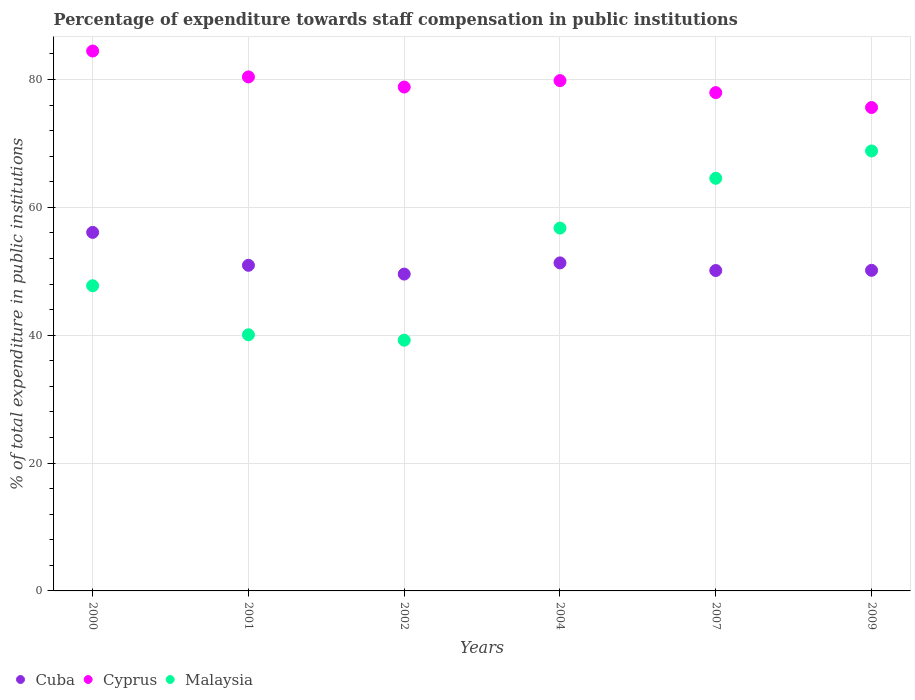What is the percentage of expenditure towards staff compensation in Cuba in 2000?
Ensure brevity in your answer.  56.08. Across all years, what is the maximum percentage of expenditure towards staff compensation in Malaysia?
Give a very brief answer. 68.82. Across all years, what is the minimum percentage of expenditure towards staff compensation in Cyprus?
Provide a short and direct response. 75.61. In which year was the percentage of expenditure towards staff compensation in Cuba maximum?
Provide a succinct answer. 2000. In which year was the percentage of expenditure towards staff compensation in Cyprus minimum?
Your answer should be compact. 2009. What is the total percentage of expenditure towards staff compensation in Cyprus in the graph?
Make the answer very short. 477.02. What is the difference between the percentage of expenditure towards staff compensation in Malaysia in 2000 and that in 2002?
Keep it short and to the point. 8.52. What is the difference between the percentage of expenditure towards staff compensation in Malaysia in 2009 and the percentage of expenditure towards staff compensation in Cyprus in 2007?
Your answer should be very brief. -9.12. What is the average percentage of expenditure towards staff compensation in Cyprus per year?
Give a very brief answer. 79.5. In the year 2004, what is the difference between the percentage of expenditure towards staff compensation in Malaysia and percentage of expenditure towards staff compensation in Cuba?
Make the answer very short. 5.44. In how many years, is the percentage of expenditure towards staff compensation in Malaysia greater than 28 %?
Provide a short and direct response. 6. What is the ratio of the percentage of expenditure towards staff compensation in Cyprus in 2000 to that in 2007?
Make the answer very short. 1.08. What is the difference between the highest and the second highest percentage of expenditure towards staff compensation in Cyprus?
Give a very brief answer. 4.05. What is the difference between the highest and the lowest percentage of expenditure towards staff compensation in Cuba?
Your answer should be compact. 6.52. Is the percentage of expenditure towards staff compensation in Cyprus strictly greater than the percentage of expenditure towards staff compensation in Malaysia over the years?
Offer a terse response. Yes. How many dotlines are there?
Give a very brief answer. 3. How many years are there in the graph?
Provide a succinct answer. 6. What is the difference between two consecutive major ticks on the Y-axis?
Your answer should be very brief. 20. Are the values on the major ticks of Y-axis written in scientific E-notation?
Keep it short and to the point. No. Does the graph contain any zero values?
Provide a succinct answer. No. Does the graph contain grids?
Make the answer very short. Yes. How many legend labels are there?
Provide a succinct answer. 3. How are the legend labels stacked?
Provide a short and direct response. Horizontal. What is the title of the graph?
Offer a terse response. Percentage of expenditure towards staff compensation in public institutions. What is the label or title of the Y-axis?
Offer a terse response. % of total expenditure in public institutions. What is the % of total expenditure in public institutions of Cuba in 2000?
Your answer should be compact. 56.08. What is the % of total expenditure in public institutions in Cyprus in 2000?
Your response must be concise. 84.44. What is the % of total expenditure in public institutions in Malaysia in 2000?
Provide a succinct answer. 47.73. What is the % of total expenditure in public institutions in Cuba in 2001?
Provide a succinct answer. 50.93. What is the % of total expenditure in public institutions of Cyprus in 2001?
Offer a terse response. 80.4. What is the % of total expenditure in public institutions in Malaysia in 2001?
Offer a terse response. 40.07. What is the % of total expenditure in public institutions in Cuba in 2002?
Your answer should be very brief. 49.56. What is the % of total expenditure in public institutions of Cyprus in 2002?
Ensure brevity in your answer.  78.81. What is the % of total expenditure in public institutions of Malaysia in 2002?
Keep it short and to the point. 39.22. What is the % of total expenditure in public institutions in Cuba in 2004?
Your answer should be compact. 51.31. What is the % of total expenditure in public institutions of Cyprus in 2004?
Your response must be concise. 79.82. What is the % of total expenditure in public institutions in Malaysia in 2004?
Provide a succinct answer. 56.75. What is the % of total expenditure in public institutions of Cuba in 2007?
Offer a very short reply. 50.11. What is the % of total expenditure in public institutions in Cyprus in 2007?
Give a very brief answer. 77.94. What is the % of total expenditure in public institutions in Malaysia in 2007?
Provide a short and direct response. 64.54. What is the % of total expenditure in public institutions in Cuba in 2009?
Your response must be concise. 50.14. What is the % of total expenditure in public institutions of Cyprus in 2009?
Make the answer very short. 75.61. What is the % of total expenditure in public institutions of Malaysia in 2009?
Provide a short and direct response. 68.82. Across all years, what is the maximum % of total expenditure in public institutions in Cuba?
Provide a short and direct response. 56.08. Across all years, what is the maximum % of total expenditure in public institutions in Cyprus?
Give a very brief answer. 84.44. Across all years, what is the maximum % of total expenditure in public institutions of Malaysia?
Your answer should be compact. 68.82. Across all years, what is the minimum % of total expenditure in public institutions of Cuba?
Your response must be concise. 49.56. Across all years, what is the minimum % of total expenditure in public institutions of Cyprus?
Make the answer very short. 75.61. Across all years, what is the minimum % of total expenditure in public institutions of Malaysia?
Provide a short and direct response. 39.22. What is the total % of total expenditure in public institutions of Cuba in the graph?
Keep it short and to the point. 308.13. What is the total % of total expenditure in public institutions of Cyprus in the graph?
Provide a succinct answer. 477.02. What is the total % of total expenditure in public institutions of Malaysia in the graph?
Your answer should be very brief. 317.12. What is the difference between the % of total expenditure in public institutions of Cuba in 2000 and that in 2001?
Offer a very short reply. 5.15. What is the difference between the % of total expenditure in public institutions in Cyprus in 2000 and that in 2001?
Ensure brevity in your answer.  4.05. What is the difference between the % of total expenditure in public institutions of Malaysia in 2000 and that in 2001?
Keep it short and to the point. 7.67. What is the difference between the % of total expenditure in public institutions in Cuba in 2000 and that in 2002?
Your answer should be very brief. 6.52. What is the difference between the % of total expenditure in public institutions of Cyprus in 2000 and that in 2002?
Ensure brevity in your answer.  5.63. What is the difference between the % of total expenditure in public institutions in Malaysia in 2000 and that in 2002?
Make the answer very short. 8.52. What is the difference between the % of total expenditure in public institutions of Cuba in 2000 and that in 2004?
Offer a terse response. 4.77. What is the difference between the % of total expenditure in public institutions in Cyprus in 2000 and that in 2004?
Keep it short and to the point. 4.63. What is the difference between the % of total expenditure in public institutions in Malaysia in 2000 and that in 2004?
Provide a short and direct response. -9.02. What is the difference between the % of total expenditure in public institutions in Cuba in 2000 and that in 2007?
Provide a short and direct response. 5.96. What is the difference between the % of total expenditure in public institutions in Cyprus in 2000 and that in 2007?
Give a very brief answer. 6.5. What is the difference between the % of total expenditure in public institutions of Malaysia in 2000 and that in 2007?
Make the answer very short. -16.81. What is the difference between the % of total expenditure in public institutions in Cuba in 2000 and that in 2009?
Offer a very short reply. 5.93. What is the difference between the % of total expenditure in public institutions of Cyprus in 2000 and that in 2009?
Give a very brief answer. 8.83. What is the difference between the % of total expenditure in public institutions in Malaysia in 2000 and that in 2009?
Offer a very short reply. -21.08. What is the difference between the % of total expenditure in public institutions of Cuba in 2001 and that in 2002?
Offer a very short reply. 1.37. What is the difference between the % of total expenditure in public institutions in Cyprus in 2001 and that in 2002?
Your answer should be compact. 1.59. What is the difference between the % of total expenditure in public institutions in Malaysia in 2001 and that in 2002?
Offer a very short reply. 0.85. What is the difference between the % of total expenditure in public institutions of Cuba in 2001 and that in 2004?
Ensure brevity in your answer.  -0.38. What is the difference between the % of total expenditure in public institutions of Cyprus in 2001 and that in 2004?
Offer a terse response. 0.58. What is the difference between the % of total expenditure in public institutions of Malaysia in 2001 and that in 2004?
Provide a succinct answer. -16.69. What is the difference between the % of total expenditure in public institutions in Cuba in 2001 and that in 2007?
Make the answer very short. 0.82. What is the difference between the % of total expenditure in public institutions in Cyprus in 2001 and that in 2007?
Give a very brief answer. 2.46. What is the difference between the % of total expenditure in public institutions in Malaysia in 2001 and that in 2007?
Provide a short and direct response. -24.47. What is the difference between the % of total expenditure in public institutions of Cuba in 2001 and that in 2009?
Your answer should be very brief. 0.79. What is the difference between the % of total expenditure in public institutions in Cyprus in 2001 and that in 2009?
Keep it short and to the point. 4.79. What is the difference between the % of total expenditure in public institutions in Malaysia in 2001 and that in 2009?
Offer a terse response. -28.75. What is the difference between the % of total expenditure in public institutions of Cuba in 2002 and that in 2004?
Ensure brevity in your answer.  -1.75. What is the difference between the % of total expenditure in public institutions of Cyprus in 2002 and that in 2004?
Your answer should be very brief. -1.01. What is the difference between the % of total expenditure in public institutions of Malaysia in 2002 and that in 2004?
Your response must be concise. -17.53. What is the difference between the % of total expenditure in public institutions in Cuba in 2002 and that in 2007?
Your answer should be very brief. -0.56. What is the difference between the % of total expenditure in public institutions of Cyprus in 2002 and that in 2007?
Offer a very short reply. 0.87. What is the difference between the % of total expenditure in public institutions of Malaysia in 2002 and that in 2007?
Your response must be concise. -25.32. What is the difference between the % of total expenditure in public institutions of Cuba in 2002 and that in 2009?
Your answer should be very brief. -0.59. What is the difference between the % of total expenditure in public institutions in Cyprus in 2002 and that in 2009?
Offer a terse response. 3.2. What is the difference between the % of total expenditure in public institutions in Malaysia in 2002 and that in 2009?
Make the answer very short. -29.6. What is the difference between the % of total expenditure in public institutions of Cuba in 2004 and that in 2007?
Ensure brevity in your answer.  1.19. What is the difference between the % of total expenditure in public institutions of Cyprus in 2004 and that in 2007?
Your answer should be very brief. 1.88. What is the difference between the % of total expenditure in public institutions of Malaysia in 2004 and that in 2007?
Provide a succinct answer. -7.79. What is the difference between the % of total expenditure in public institutions in Cuba in 2004 and that in 2009?
Offer a terse response. 1.16. What is the difference between the % of total expenditure in public institutions in Cyprus in 2004 and that in 2009?
Make the answer very short. 4.21. What is the difference between the % of total expenditure in public institutions in Malaysia in 2004 and that in 2009?
Offer a terse response. -12.06. What is the difference between the % of total expenditure in public institutions of Cuba in 2007 and that in 2009?
Your answer should be compact. -0.03. What is the difference between the % of total expenditure in public institutions of Cyprus in 2007 and that in 2009?
Provide a succinct answer. 2.33. What is the difference between the % of total expenditure in public institutions of Malaysia in 2007 and that in 2009?
Offer a terse response. -4.28. What is the difference between the % of total expenditure in public institutions of Cuba in 2000 and the % of total expenditure in public institutions of Cyprus in 2001?
Keep it short and to the point. -24.32. What is the difference between the % of total expenditure in public institutions of Cuba in 2000 and the % of total expenditure in public institutions of Malaysia in 2001?
Your response must be concise. 16.01. What is the difference between the % of total expenditure in public institutions of Cyprus in 2000 and the % of total expenditure in public institutions of Malaysia in 2001?
Your answer should be very brief. 44.38. What is the difference between the % of total expenditure in public institutions in Cuba in 2000 and the % of total expenditure in public institutions in Cyprus in 2002?
Your answer should be compact. -22.73. What is the difference between the % of total expenditure in public institutions of Cuba in 2000 and the % of total expenditure in public institutions of Malaysia in 2002?
Your response must be concise. 16.86. What is the difference between the % of total expenditure in public institutions in Cyprus in 2000 and the % of total expenditure in public institutions in Malaysia in 2002?
Your answer should be very brief. 45.23. What is the difference between the % of total expenditure in public institutions in Cuba in 2000 and the % of total expenditure in public institutions in Cyprus in 2004?
Keep it short and to the point. -23.74. What is the difference between the % of total expenditure in public institutions in Cuba in 2000 and the % of total expenditure in public institutions in Malaysia in 2004?
Make the answer very short. -0.67. What is the difference between the % of total expenditure in public institutions of Cyprus in 2000 and the % of total expenditure in public institutions of Malaysia in 2004?
Keep it short and to the point. 27.69. What is the difference between the % of total expenditure in public institutions of Cuba in 2000 and the % of total expenditure in public institutions of Cyprus in 2007?
Provide a succinct answer. -21.86. What is the difference between the % of total expenditure in public institutions in Cuba in 2000 and the % of total expenditure in public institutions in Malaysia in 2007?
Provide a succinct answer. -8.46. What is the difference between the % of total expenditure in public institutions of Cyprus in 2000 and the % of total expenditure in public institutions of Malaysia in 2007?
Offer a very short reply. 19.9. What is the difference between the % of total expenditure in public institutions in Cuba in 2000 and the % of total expenditure in public institutions in Cyprus in 2009?
Your response must be concise. -19.53. What is the difference between the % of total expenditure in public institutions of Cuba in 2000 and the % of total expenditure in public institutions of Malaysia in 2009?
Offer a terse response. -12.74. What is the difference between the % of total expenditure in public institutions of Cyprus in 2000 and the % of total expenditure in public institutions of Malaysia in 2009?
Offer a very short reply. 15.63. What is the difference between the % of total expenditure in public institutions of Cuba in 2001 and the % of total expenditure in public institutions of Cyprus in 2002?
Ensure brevity in your answer.  -27.88. What is the difference between the % of total expenditure in public institutions in Cuba in 2001 and the % of total expenditure in public institutions in Malaysia in 2002?
Offer a terse response. 11.71. What is the difference between the % of total expenditure in public institutions of Cyprus in 2001 and the % of total expenditure in public institutions of Malaysia in 2002?
Keep it short and to the point. 41.18. What is the difference between the % of total expenditure in public institutions of Cuba in 2001 and the % of total expenditure in public institutions of Cyprus in 2004?
Your answer should be compact. -28.89. What is the difference between the % of total expenditure in public institutions of Cuba in 2001 and the % of total expenditure in public institutions of Malaysia in 2004?
Your response must be concise. -5.82. What is the difference between the % of total expenditure in public institutions of Cyprus in 2001 and the % of total expenditure in public institutions of Malaysia in 2004?
Provide a succinct answer. 23.65. What is the difference between the % of total expenditure in public institutions of Cuba in 2001 and the % of total expenditure in public institutions of Cyprus in 2007?
Offer a terse response. -27.01. What is the difference between the % of total expenditure in public institutions in Cuba in 2001 and the % of total expenditure in public institutions in Malaysia in 2007?
Provide a short and direct response. -13.61. What is the difference between the % of total expenditure in public institutions of Cyprus in 2001 and the % of total expenditure in public institutions of Malaysia in 2007?
Give a very brief answer. 15.86. What is the difference between the % of total expenditure in public institutions of Cuba in 2001 and the % of total expenditure in public institutions of Cyprus in 2009?
Provide a succinct answer. -24.68. What is the difference between the % of total expenditure in public institutions of Cuba in 2001 and the % of total expenditure in public institutions of Malaysia in 2009?
Your response must be concise. -17.89. What is the difference between the % of total expenditure in public institutions in Cyprus in 2001 and the % of total expenditure in public institutions in Malaysia in 2009?
Offer a very short reply. 11.58. What is the difference between the % of total expenditure in public institutions in Cuba in 2002 and the % of total expenditure in public institutions in Cyprus in 2004?
Provide a short and direct response. -30.26. What is the difference between the % of total expenditure in public institutions of Cuba in 2002 and the % of total expenditure in public institutions of Malaysia in 2004?
Make the answer very short. -7.19. What is the difference between the % of total expenditure in public institutions in Cyprus in 2002 and the % of total expenditure in public institutions in Malaysia in 2004?
Your answer should be compact. 22.06. What is the difference between the % of total expenditure in public institutions in Cuba in 2002 and the % of total expenditure in public institutions in Cyprus in 2007?
Ensure brevity in your answer.  -28.38. What is the difference between the % of total expenditure in public institutions of Cuba in 2002 and the % of total expenditure in public institutions of Malaysia in 2007?
Provide a succinct answer. -14.98. What is the difference between the % of total expenditure in public institutions in Cyprus in 2002 and the % of total expenditure in public institutions in Malaysia in 2007?
Provide a succinct answer. 14.27. What is the difference between the % of total expenditure in public institutions of Cuba in 2002 and the % of total expenditure in public institutions of Cyprus in 2009?
Your response must be concise. -26.05. What is the difference between the % of total expenditure in public institutions of Cuba in 2002 and the % of total expenditure in public institutions of Malaysia in 2009?
Keep it short and to the point. -19.26. What is the difference between the % of total expenditure in public institutions of Cyprus in 2002 and the % of total expenditure in public institutions of Malaysia in 2009?
Provide a succinct answer. 10. What is the difference between the % of total expenditure in public institutions in Cuba in 2004 and the % of total expenditure in public institutions in Cyprus in 2007?
Make the answer very short. -26.63. What is the difference between the % of total expenditure in public institutions of Cuba in 2004 and the % of total expenditure in public institutions of Malaysia in 2007?
Ensure brevity in your answer.  -13.23. What is the difference between the % of total expenditure in public institutions in Cyprus in 2004 and the % of total expenditure in public institutions in Malaysia in 2007?
Your response must be concise. 15.28. What is the difference between the % of total expenditure in public institutions in Cuba in 2004 and the % of total expenditure in public institutions in Cyprus in 2009?
Make the answer very short. -24.3. What is the difference between the % of total expenditure in public institutions in Cuba in 2004 and the % of total expenditure in public institutions in Malaysia in 2009?
Your answer should be very brief. -17.51. What is the difference between the % of total expenditure in public institutions of Cyprus in 2004 and the % of total expenditure in public institutions of Malaysia in 2009?
Your response must be concise. 11. What is the difference between the % of total expenditure in public institutions in Cuba in 2007 and the % of total expenditure in public institutions in Cyprus in 2009?
Your response must be concise. -25.5. What is the difference between the % of total expenditure in public institutions in Cuba in 2007 and the % of total expenditure in public institutions in Malaysia in 2009?
Give a very brief answer. -18.7. What is the difference between the % of total expenditure in public institutions of Cyprus in 2007 and the % of total expenditure in public institutions of Malaysia in 2009?
Provide a succinct answer. 9.12. What is the average % of total expenditure in public institutions in Cuba per year?
Make the answer very short. 51.36. What is the average % of total expenditure in public institutions of Cyprus per year?
Keep it short and to the point. 79.5. What is the average % of total expenditure in public institutions in Malaysia per year?
Your response must be concise. 52.85. In the year 2000, what is the difference between the % of total expenditure in public institutions in Cuba and % of total expenditure in public institutions in Cyprus?
Give a very brief answer. -28.37. In the year 2000, what is the difference between the % of total expenditure in public institutions of Cuba and % of total expenditure in public institutions of Malaysia?
Ensure brevity in your answer.  8.35. In the year 2000, what is the difference between the % of total expenditure in public institutions of Cyprus and % of total expenditure in public institutions of Malaysia?
Offer a terse response. 36.71. In the year 2001, what is the difference between the % of total expenditure in public institutions of Cuba and % of total expenditure in public institutions of Cyprus?
Make the answer very short. -29.47. In the year 2001, what is the difference between the % of total expenditure in public institutions of Cuba and % of total expenditure in public institutions of Malaysia?
Give a very brief answer. 10.86. In the year 2001, what is the difference between the % of total expenditure in public institutions in Cyprus and % of total expenditure in public institutions in Malaysia?
Give a very brief answer. 40.33. In the year 2002, what is the difference between the % of total expenditure in public institutions of Cuba and % of total expenditure in public institutions of Cyprus?
Keep it short and to the point. -29.25. In the year 2002, what is the difference between the % of total expenditure in public institutions in Cuba and % of total expenditure in public institutions in Malaysia?
Provide a succinct answer. 10.34. In the year 2002, what is the difference between the % of total expenditure in public institutions of Cyprus and % of total expenditure in public institutions of Malaysia?
Make the answer very short. 39.6. In the year 2004, what is the difference between the % of total expenditure in public institutions in Cuba and % of total expenditure in public institutions in Cyprus?
Your response must be concise. -28.51. In the year 2004, what is the difference between the % of total expenditure in public institutions of Cuba and % of total expenditure in public institutions of Malaysia?
Offer a very short reply. -5.44. In the year 2004, what is the difference between the % of total expenditure in public institutions in Cyprus and % of total expenditure in public institutions in Malaysia?
Make the answer very short. 23.07. In the year 2007, what is the difference between the % of total expenditure in public institutions in Cuba and % of total expenditure in public institutions in Cyprus?
Make the answer very short. -27.83. In the year 2007, what is the difference between the % of total expenditure in public institutions of Cuba and % of total expenditure in public institutions of Malaysia?
Keep it short and to the point. -14.43. In the year 2007, what is the difference between the % of total expenditure in public institutions in Cyprus and % of total expenditure in public institutions in Malaysia?
Keep it short and to the point. 13.4. In the year 2009, what is the difference between the % of total expenditure in public institutions in Cuba and % of total expenditure in public institutions in Cyprus?
Make the answer very short. -25.47. In the year 2009, what is the difference between the % of total expenditure in public institutions in Cuba and % of total expenditure in public institutions in Malaysia?
Your response must be concise. -18.67. In the year 2009, what is the difference between the % of total expenditure in public institutions in Cyprus and % of total expenditure in public institutions in Malaysia?
Ensure brevity in your answer.  6.8. What is the ratio of the % of total expenditure in public institutions of Cuba in 2000 to that in 2001?
Keep it short and to the point. 1.1. What is the ratio of the % of total expenditure in public institutions in Cyprus in 2000 to that in 2001?
Provide a short and direct response. 1.05. What is the ratio of the % of total expenditure in public institutions of Malaysia in 2000 to that in 2001?
Your answer should be very brief. 1.19. What is the ratio of the % of total expenditure in public institutions in Cuba in 2000 to that in 2002?
Provide a succinct answer. 1.13. What is the ratio of the % of total expenditure in public institutions of Cyprus in 2000 to that in 2002?
Provide a short and direct response. 1.07. What is the ratio of the % of total expenditure in public institutions in Malaysia in 2000 to that in 2002?
Ensure brevity in your answer.  1.22. What is the ratio of the % of total expenditure in public institutions in Cuba in 2000 to that in 2004?
Your answer should be very brief. 1.09. What is the ratio of the % of total expenditure in public institutions of Cyprus in 2000 to that in 2004?
Offer a very short reply. 1.06. What is the ratio of the % of total expenditure in public institutions in Malaysia in 2000 to that in 2004?
Your answer should be very brief. 0.84. What is the ratio of the % of total expenditure in public institutions in Cuba in 2000 to that in 2007?
Keep it short and to the point. 1.12. What is the ratio of the % of total expenditure in public institutions in Cyprus in 2000 to that in 2007?
Offer a terse response. 1.08. What is the ratio of the % of total expenditure in public institutions of Malaysia in 2000 to that in 2007?
Provide a succinct answer. 0.74. What is the ratio of the % of total expenditure in public institutions in Cuba in 2000 to that in 2009?
Provide a succinct answer. 1.12. What is the ratio of the % of total expenditure in public institutions in Cyprus in 2000 to that in 2009?
Keep it short and to the point. 1.12. What is the ratio of the % of total expenditure in public institutions of Malaysia in 2000 to that in 2009?
Offer a terse response. 0.69. What is the ratio of the % of total expenditure in public institutions in Cuba in 2001 to that in 2002?
Your answer should be compact. 1.03. What is the ratio of the % of total expenditure in public institutions in Cyprus in 2001 to that in 2002?
Give a very brief answer. 1.02. What is the ratio of the % of total expenditure in public institutions in Malaysia in 2001 to that in 2002?
Give a very brief answer. 1.02. What is the ratio of the % of total expenditure in public institutions of Cuba in 2001 to that in 2004?
Provide a short and direct response. 0.99. What is the ratio of the % of total expenditure in public institutions of Cyprus in 2001 to that in 2004?
Make the answer very short. 1.01. What is the ratio of the % of total expenditure in public institutions of Malaysia in 2001 to that in 2004?
Your answer should be compact. 0.71. What is the ratio of the % of total expenditure in public institutions of Cuba in 2001 to that in 2007?
Offer a terse response. 1.02. What is the ratio of the % of total expenditure in public institutions of Cyprus in 2001 to that in 2007?
Keep it short and to the point. 1.03. What is the ratio of the % of total expenditure in public institutions of Malaysia in 2001 to that in 2007?
Your answer should be very brief. 0.62. What is the ratio of the % of total expenditure in public institutions in Cuba in 2001 to that in 2009?
Your answer should be very brief. 1.02. What is the ratio of the % of total expenditure in public institutions of Cyprus in 2001 to that in 2009?
Provide a succinct answer. 1.06. What is the ratio of the % of total expenditure in public institutions of Malaysia in 2001 to that in 2009?
Ensure brevity in your answer.  0.58. What is the ratio of the % of total expenditure in public institutions in Cuba in 2002 to that in 2004?
Your answer should be compact. 0.97. What is the ratio of the % of total expenditure in public institutions in Cyprus in 2002 to that in 2004?
Your answer should be compact. 0.99. What is the ratio of the % of total expenditure in public institutions in Malaysia in 2002 to that in 2004?
Ensure brevity in your answer.  0.69. What is the ratio of the % of total expenditure in public institutions of Cuba in 2002 to that in 2007?
Your response must be concise. 0.99. What is the ratio of the % of total expenditure in public institutions of Cyprus in 2002 to that in 2007?
Provide a short and direct response. 1.01. What is the ratio of the % of total expenditure in public institutions in Malaysia in 2002 to that in 2007?
Keep it short and to the point. 0.61. What is the ratio of the % of total expenditure in public institutions of Cuba in 2002 to that in 2009?
Your answer should be compact. 0.99. What is the ratio of the % of total expenditure in public institutions in Cyprus in 2002 to that in 2009?
Your answer should be very brief. 1.04. What is the ratio of the % of total expenditure in public institutions of Malaysia in 2002 to that in 2009?
Your answer should be very brief. 0.57. What is the ratio of the % of total expenditure in public institutions of Cuba in 2004 to that in 2007?
Offer a terse response. 1.02. What is the ratio of the % of total expenditure in public institutions of Cyprus in 2004 to that in 2007?
Offer a terse response. 1.02. What is the ratio of the % of total expenditure in public institutions in Malaysia in 2004 to that in 2007?
Your response must be concise. 0.88. What is the ratio of the % of total expenditure in public institutions in Cuba in 2004 to that in 2009?
Offer a very short reply. 1.02. What is the ratio of the % of total expenditure in public institutions of Cyprus in 2004 to that in 2009?
Your answer should be very brief. 1.06. What is the ratio of the % of total expenditure in public institutions of Malaysia in 2004 to that in 2009?
Your answer should be compact. 0.82. What is the ratio of the % of total expenditure in public institutions of Cuba in 2007 to that in 2009?
Your answer should be very brief. 1. What is the ratio of the % of total expenditure in public institutions of Cyprus in 2007 to that in 2009?
Offer a terse response. 1.03. What is the ratio of the % of total expenditure in public institutions in Malaysia in 2007 to that in 2009?
Make the answer very short. 0.94. What is the difference between the highest and the second highest % of total expenditure in public institutions in Cuba?
Keep it short and to the point. 4.77. What is the difference between the highest and the second highest % of total expenditure in public institutions in Cyprus?
Keep it short and to the point. 4.05. What is the difference between the highest and the second highest % of total expenditure in public institutions in Malaysia?
Make the answer very short. 4.28. What is the difference between the highest and the lowest % of total expenditure in public institutions in Cuba?
Make the answer very short. 6.52. What is the difference between the highest and the lowest % of total expenditure in public institutions in Cyprus?
Provide a short and direct response. 8.83. What is the difference between the highest and the lowest % of total expenditure in public institutions in Malaysia?
Give a very brief answer. 29.6. 